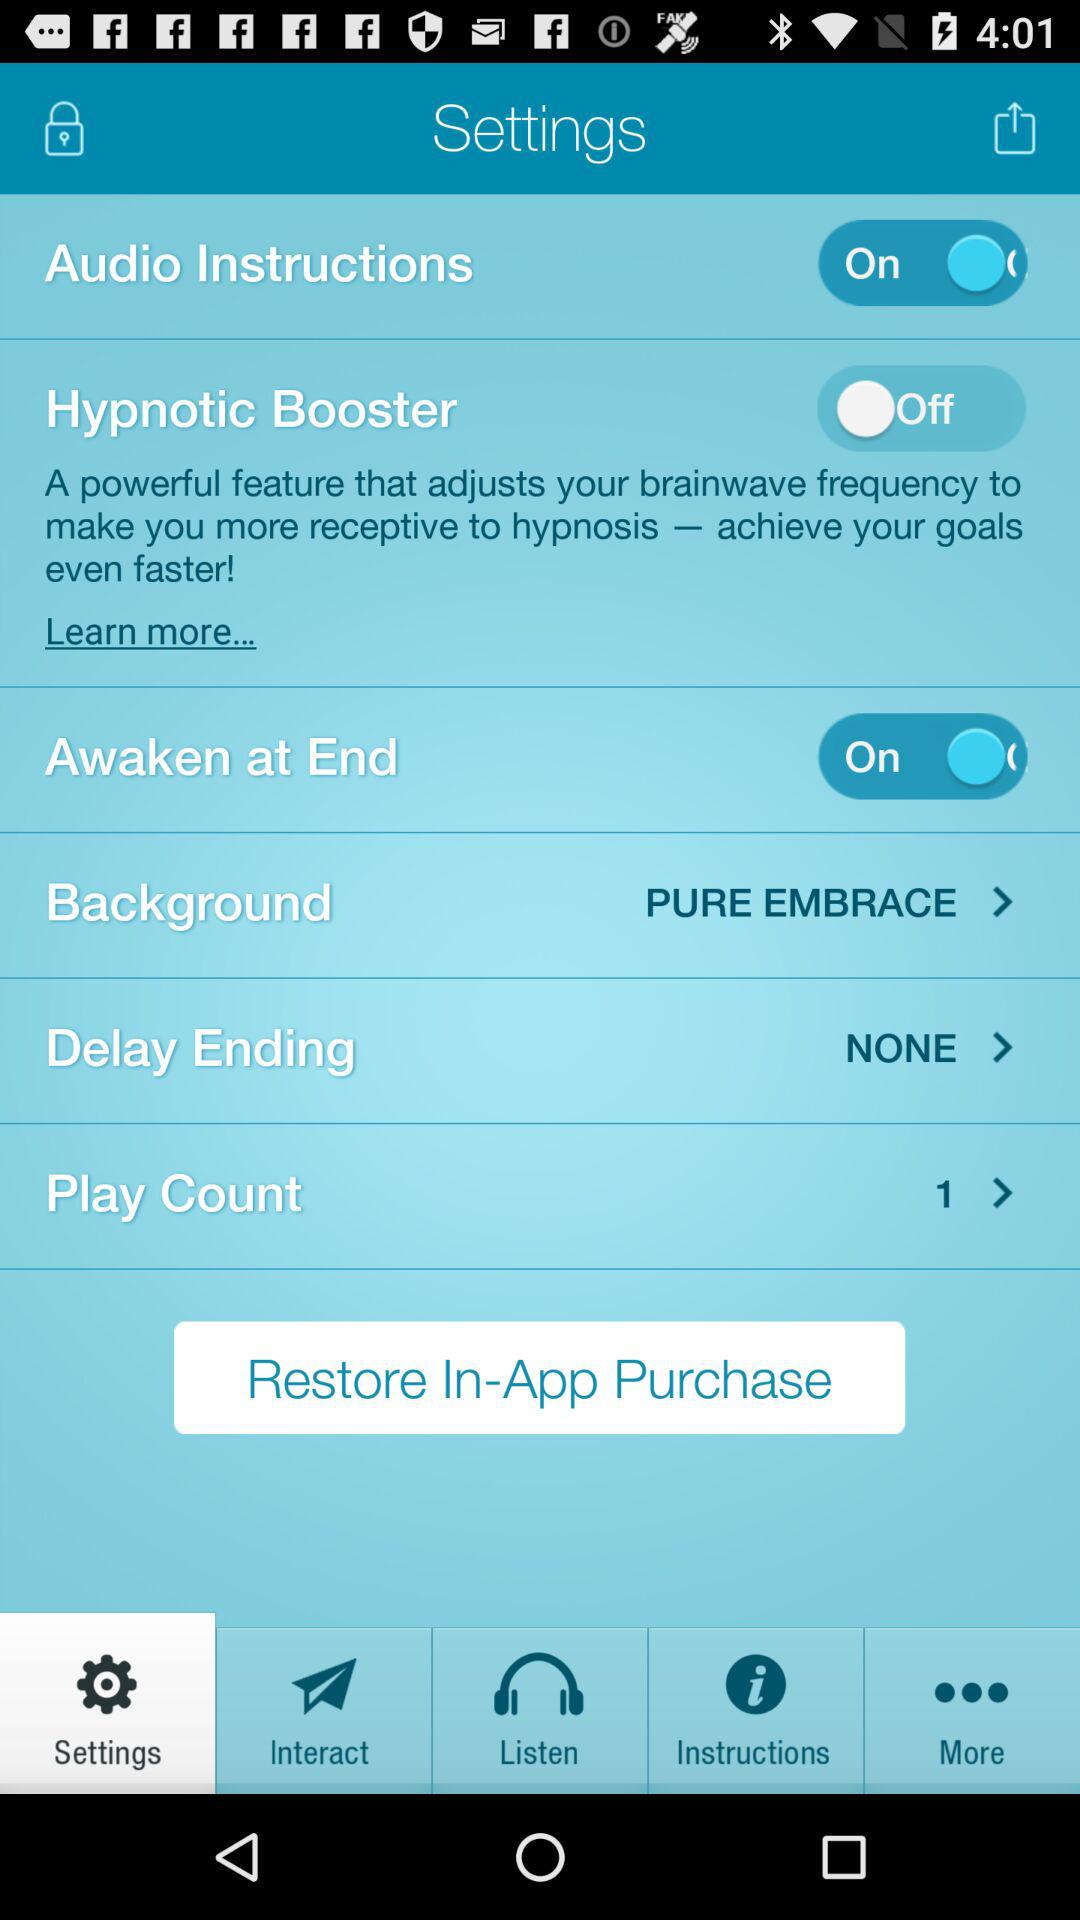What is the total "Play Count"? The total "Play Count" is 1. 